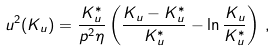<formula> <loc_0><loc_0><loc_500><loc_500>u ^ { 2 } ( K _ { u } ) = \frac { K _ { u } ^ { * } } { p ^ { 2 } \eta } \left ( \frac { K _ { u } - K _ { u } ^ { * } } { K _ { u } ^ { * } } - \ln { \frac { K _ { u } } { K _ { u } ^ { * } } } \right ) \, ,</formula> 